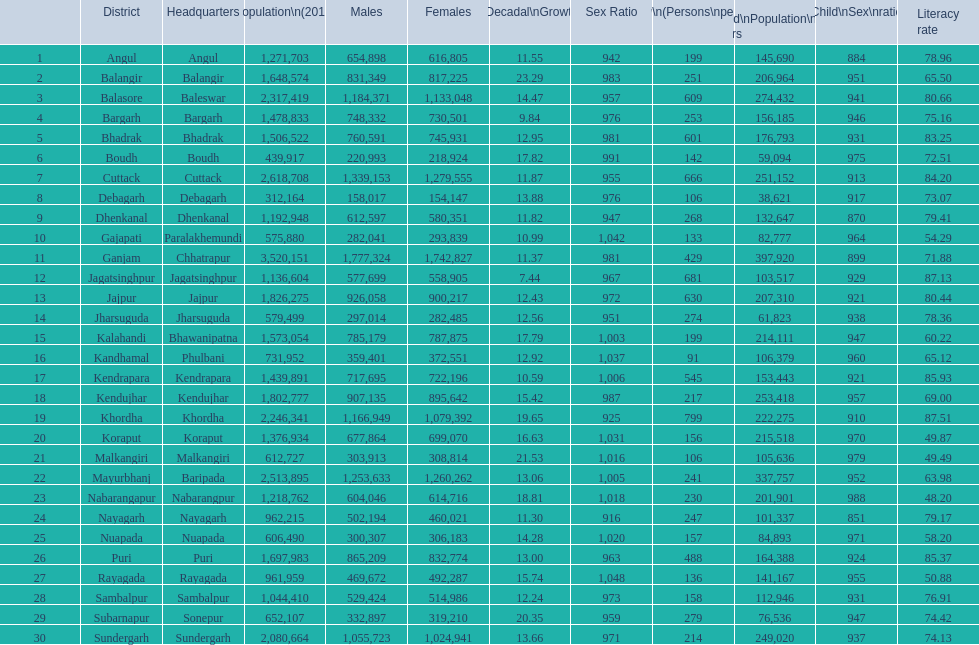What is the female population in cuttack? 1,279,555. 